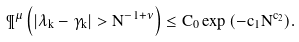<formula> <loc_0><loc_0><loc_500><loc_500>\P ^ { \mu } \left ( | \lambda _ { k } - \gamma _ { k } | > N ^ { - 1 + \nu } \right ) \leq C _ { 0 } \exp { ( - c _ { 1 } N ^ { c _ { 2 } } ) } .</formula> 